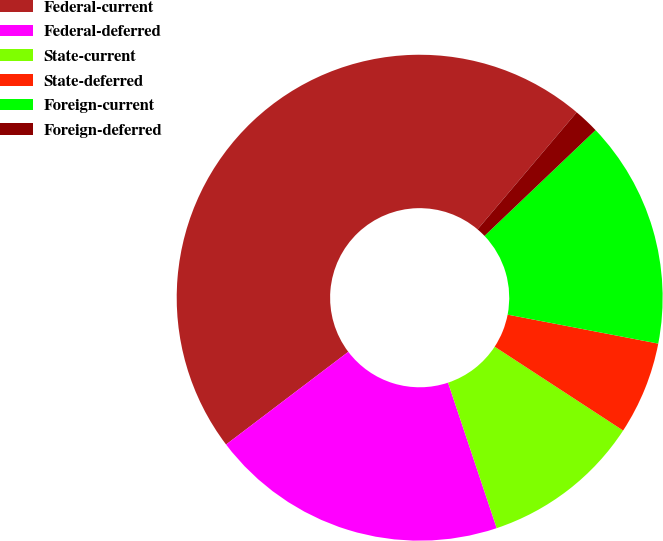Convert chart. <chart><loc_0><loc_0><loc_500><loc_500><pie_chart><fcel>Federal-current<fcel>Federal-deferred<fcel>State-current<fcel>State-deferred<fcel>Foreign-current<fcel>Foreign-deferred<nl><fcel>46.51%<fcel>19.81%<fcel>10.66%<fcel>6.18%<fcel>15.14%<fcel>1.7%<nl></chart> 